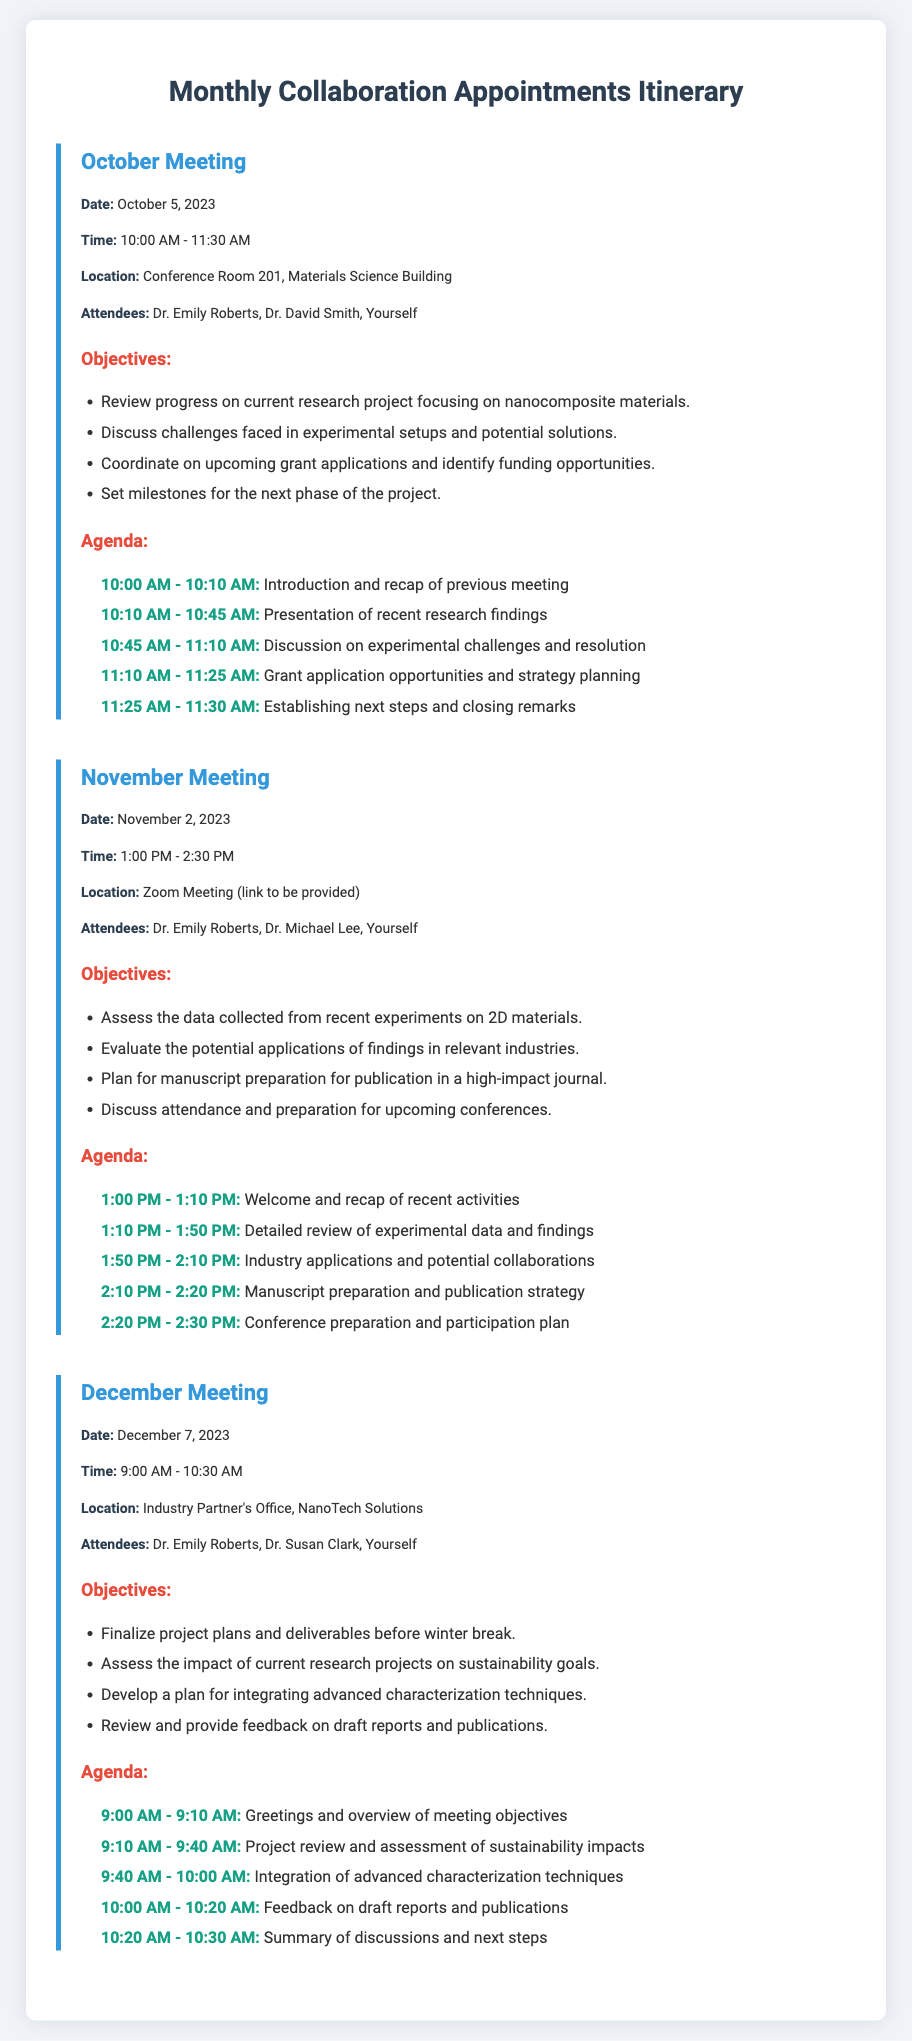What is the date of the October meeting? The date of the October meeting is explicitly stated in the document.
Answer: October 5, 2023 Who is attending the November meeting? The attendees for the November meeting include specific individuals listed in the document.
Answer: Dr. Emily Roberts, Dr. Michael Lee, Yourself What is one objective for the December meeting? The objectives for the December meeting are listed clearly in the document, providing multiple aims for the meeting.
Answer: Finalize project plans and deliverables before winter break What time does the October meeting start? The start time for the October meeting is provided in the meeting information section.
Answer: 10:00 AM How long is the November meeting scheduled to last? The duration of the November meeting can be calculated based on the start and end times given.
Answer: 1 hour 30 minutes Which meeting is scheduled to take place at an industry partner's office? The location of the December meeting indicates it will be held at an industry partner's office.
Answer: December Meeting What is being discussed during the 10:10 AM - 10:45 AM slot in the October meeting? The agenda for the October meeting provides the topics discussed during specific time slots.
Answer: Presentation of recent research findings What is the main focus of the objectives in the November meeting? The objectives for the November meeting reveal the primary themes discussed during that session.
Answer: Assess the data collected from recent experiments on 2D materials What is one topic to be covered in the agenda of the December meeting? The agenda for the December meeting lists specific topics for discussion, detailing the structure of the meeting.
Answer: Integration of advanced characterization techniques 